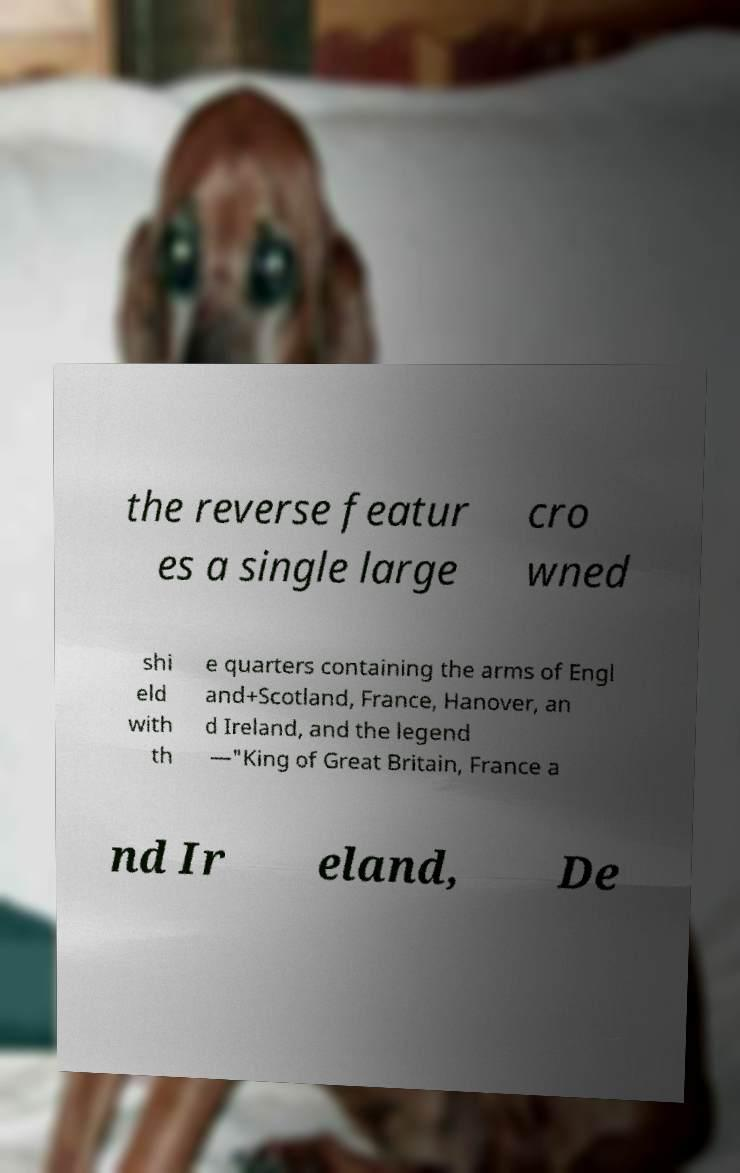Can you read and provide the text displayed in the image?This photo seems to have some interesting text. Can you extract and type it out for me? the reverse featur es a single large cro wned shi eld with th e quarters containing the arms of Engl and+Scotland, France, Hanover, an d Ireland, and the legend —"King of Great Britain, France a nd Ir eland, De 